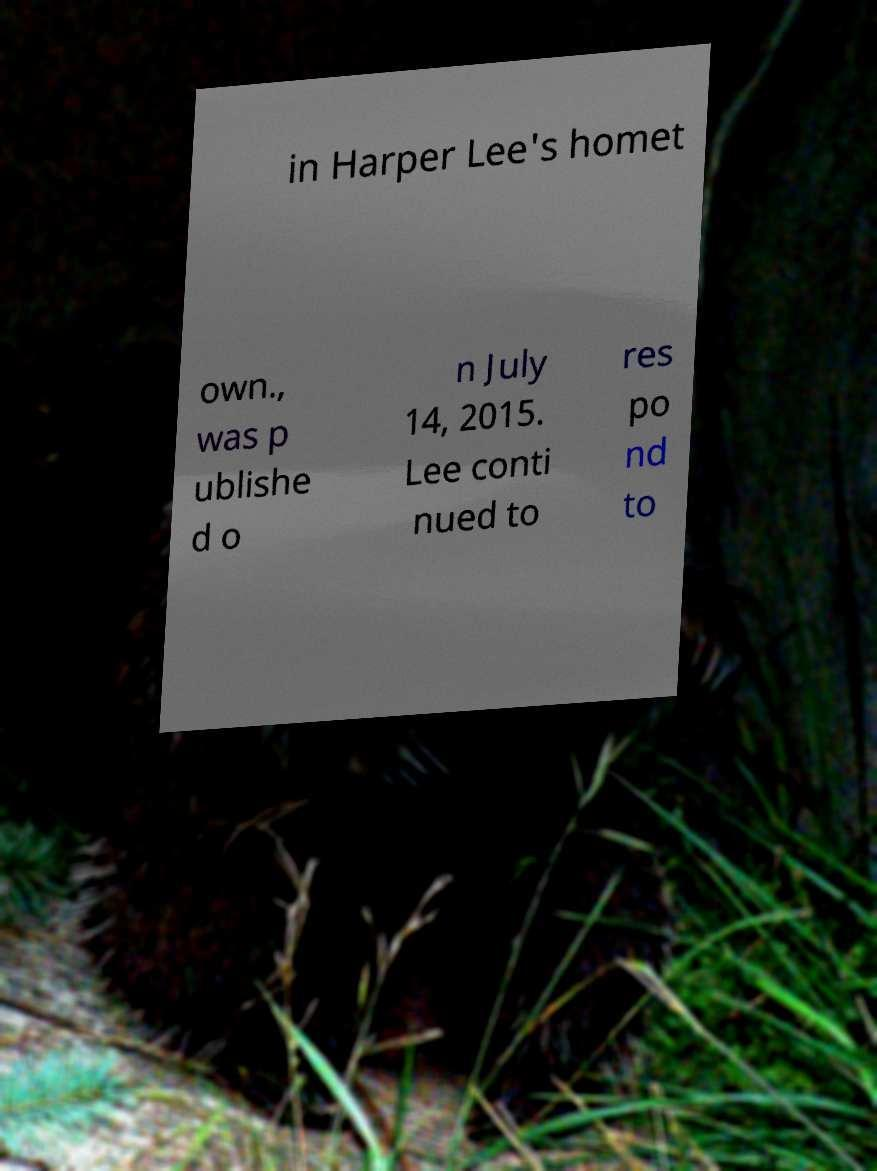There's text embedded in this image that I need extracted. Can you transcribe it verbatim? in Harper Lee's homet own., was p ublishe d o n July 14, 2015. Lee conti nued to res po nd to 